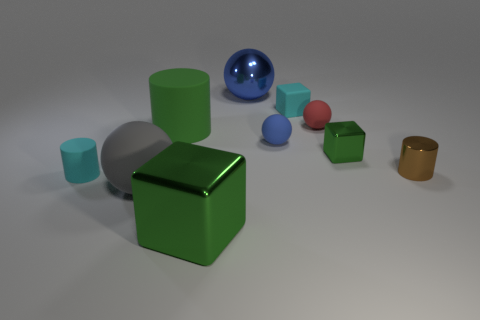Subtract all big green cubes. How many cubes are left? 2 Subtract all cyan cylinders. How many blue balls are left? 2 Subtract all green cylinders. How many cylinders are left? 2 Subtract 1 balls. How many balls are left? 3 Subtract all balls. How many objects are left? 6 Subtract all red cylinders. Subtract all brown spheres. How many cylinders are left? 3 Subtract all large cylinders. Subtract all small brown things. How many objects are left? 8 Add 2 tiny blue matte balls. How many tiny blue matte balls are left? 3 Add 3 yellow metallic objects. How many yellow metallic objects exist? 3 Subtract 0 brown spheres. How many objects are left? 10 